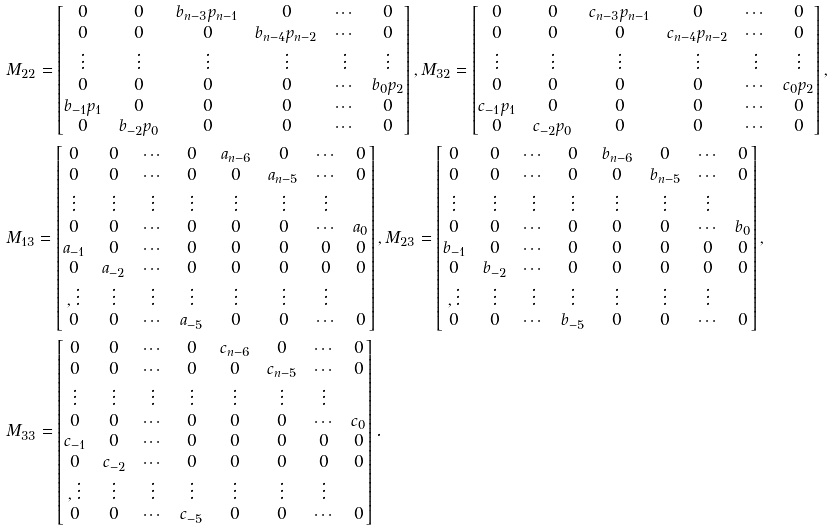Convert formula to latex. <formula><loc_0><loc_0><loc_500><loc_500>& M _ { 2 2 } = \begin{bmatrix} 0 & 0 & b _ { n - 3 } p _ { n - 1 } & 0 & \cdots & 0 \\ 0 & 0 & 0 & b _ { n - 4 } p _ { n - 2 } & \cdots & 0 \\ \vdots & \vdots & \vdots & \vdots & \vdots & \vdots \\ 0 & 0 & 0 & 0 & \cdots & b _ { 0 } p _ { 2 } \\ b _ { - 1 } p _ { 1 } & 0 & 0 & 0 & \cdots & 0 \\ 0 & b _ { - 2 } p _ { 0 } & 0 & 0 & \cdots & 0 \\ \end{bmatrix} , M _ { 3 2 } = \begin{bmatrix} 0 & 0 & c _ { n - 3 } p _ { n - 1 } & 0 & \cdots & 0 \\ 0 & 0 & 0 & c _ { n - 4 } p _ { n - 2 } & \cdots & 0 \\ \vdots & \vdots & \vdots & \vdots & \vdots & \vdots \\ 0 & 0 & 0 & 0 & \cdots & c _ { 0 } p _ { 2 } \\ c _ { - 1 } p _ { 1 } & 0 & 0 & 0 & \cdots & 0 \\ 0 & c _ { - 2 } p _ { 0 } & 0 & 0 & \cdots & 0 \\ \end{bmatrix} , \\ & M _ { 1 3 } = \begin{bmatrix} 0 & 0 & \cdots & 0 & a _ { n - 6 } & 0 & \cdots & 0 \\ 0 & 0 & \cdots & 0 & 0 & a _ { n - 5 } & \cdots & 0 \\ \vdots & \vdots & \vdots & \vdots & \vdots & \vdots & \vdots \\ 0 & 0 & \cdots & 0 & 0 & 0 & \cdots & a _ { 0 } \\ a _ { - 1 } & 0 & \cdots & 0 & 0 & 0 & 0 & 0 \\ 0 & a _ { - 2 } & \cdots & 0 & 0 & 0 & 0 & 0 \\ , \vdots & \vdots & \vdots & \vdots & \vdots & \vdots & \vdots \\ 0 & 0 & \cdots & a _ { - 5 } & 0 & 0 & \cdots & 0 \end{bmatrix} , M _ { 2 3 } = \begin{bmatrix} 0 & 0 & \cdots & 0 & b _ { n - 6 } & 0 & \cdots & 0 \\ 0 & 0 & \cdots & 0 & 0 & b _ { n - 5 } & \cdots & 0 \\ \vdots & \vdots & \vdots & \vdots & \vdots & \vdots & \vdots \\ 0 & 0 & \cdots & 0 & 0 & 0 & \cdots & b _ { 0 } \\ b _ { - 1 } & 0 & \cdots & 0 & 0 & 0 & 0 & 0 \\ 0 & b _ { - 2 } & \cdots & 0 & 0 & 0 & 0 & 0 \\ , \vdots & \vdots & \vdots & \vdots & \vdots & \vdots & \vdots \\ 0 & 0 & \cdots & b _ { - 5 } & 0 & 0 & \cdots & 0 \end{bmatrix} , \\ & M _ { 3 3 } = \begin{bmatrix} 0 & 0 & \cdots & 0 & c _ { n - 6 } & 0 & \cdots & 0 \\ 0 & 0 & \cdots & 0 & 0 & c _ { n - 5 } & \cdots & 0 \\ \vdots & \vdots & \vdots & \vdots & \vdots & \vdots & \vdots \\ 0 & 0 & \cdots & 0 & 0 & 0 & \cdots & c _ { 0 } \\ c _ { - 1 } & 0 & \cdots & 0 & 0 & 0 & 0 & 0 \\ 0 & c _ { - 2 } & \cdots & 0 & 0 & 0 & 0 & 0 \\ , \vdots & \vdots & \vdots & \vdots & \vdots & \vdots & \vdots \\ 0 & 0 & \cdots & c _ { - 5 } & 0 & 0 & \cdots & 0 \end{bmatrix} .</formula> 